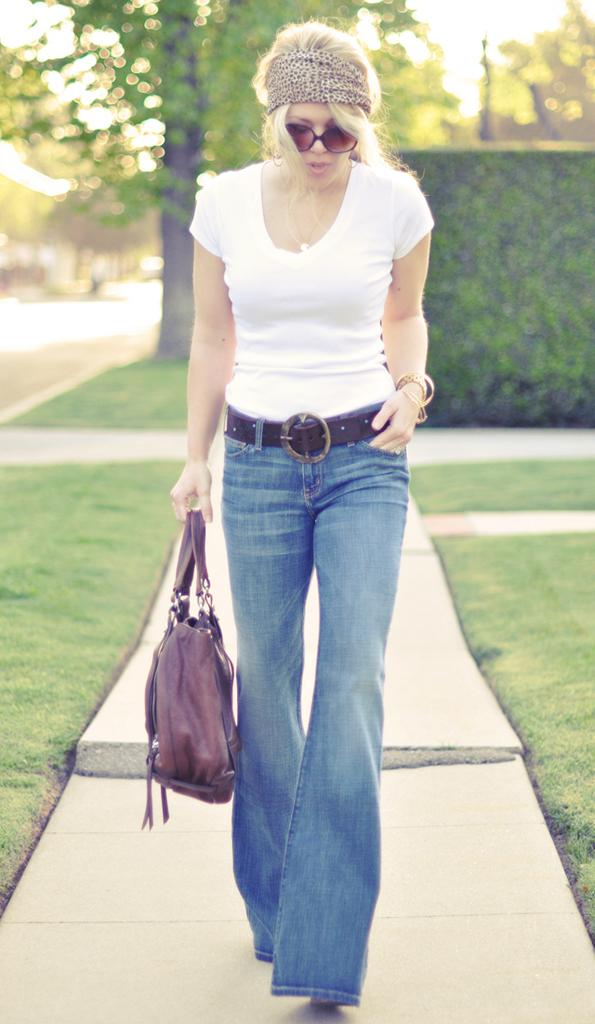Who is the main subject in the image? There is a woman in the image. What is the woman doing in the image? The woman is walking. What is the woman holding in the image? The woman is holding a bag. What type of natural environment is visible in the image? There are trees and grass in the image. What type of prose is the woman reading while walking in the image? There is no indication in the image that the woman is reading any prose, as she is walking and holding a bag. 